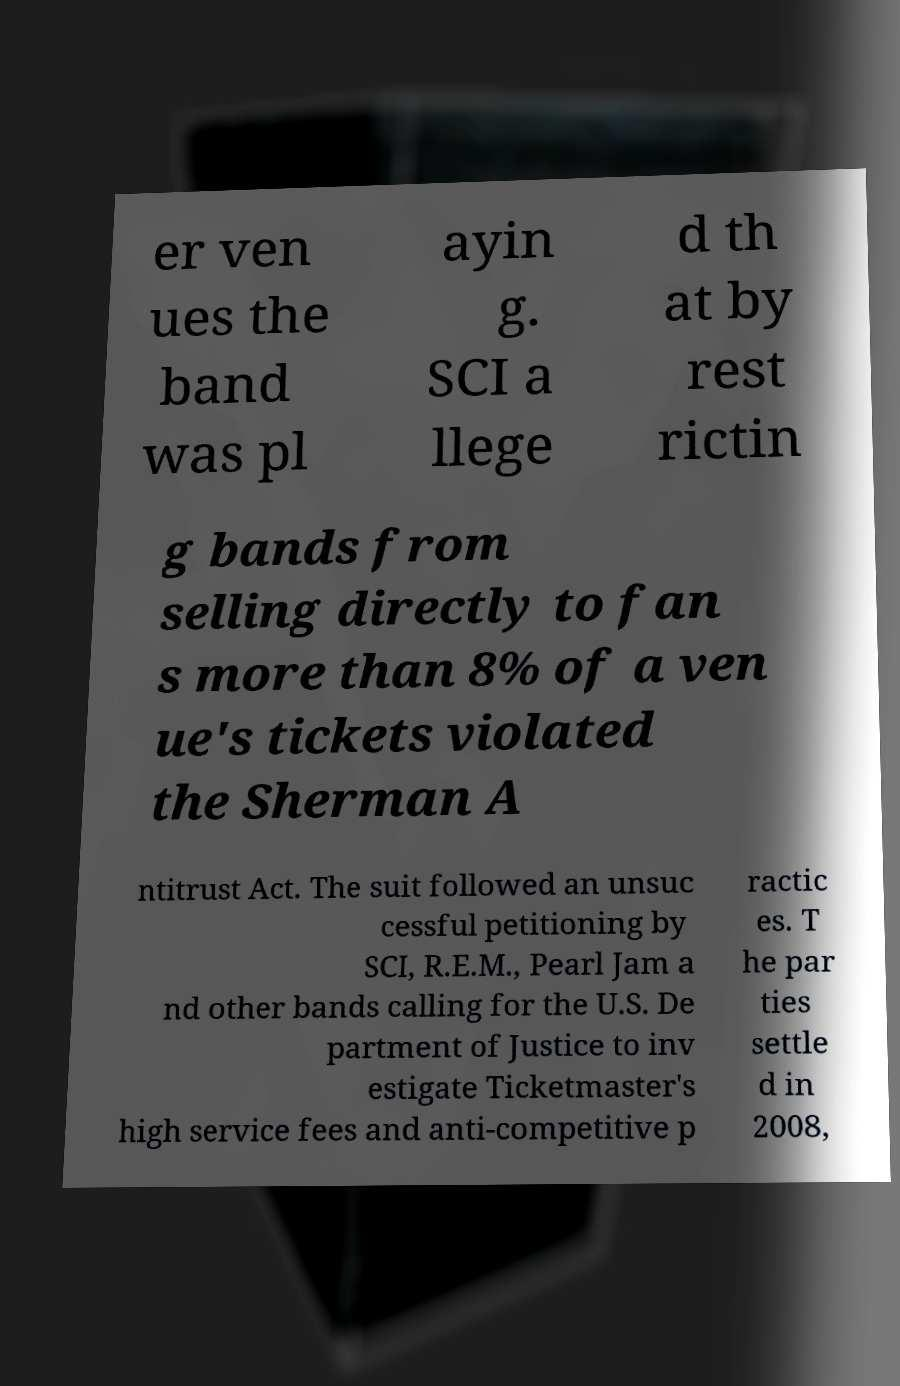Can you read and provide the text displayed in the image?This photo seems to have some interesting text. Can you extract and type it out for me? er ven ues the band was pl ayin g. SCI a llege d th at by rest rictin g bands from selling directly to fan s more than 8% of a ven ue's tickets violated the Sherman A ntitrust Act. The suit followed an unsuc cessful petitioning by SCI, R.E.M., Pearl Jam a nd other bands calling for the U.S. De partment of Justice to inv estigate Ticketmaster's high service fees and anti-competitive p ractic es. T he par ties settle d in 2008, 